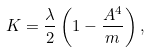<formula> <loc_0><loc_0><loc_500><loc_500>K = \frac { \lambda } { 2 } \left ( 1 - \frac { A ^ { 4 } } { m } \right ) ,</formula> 